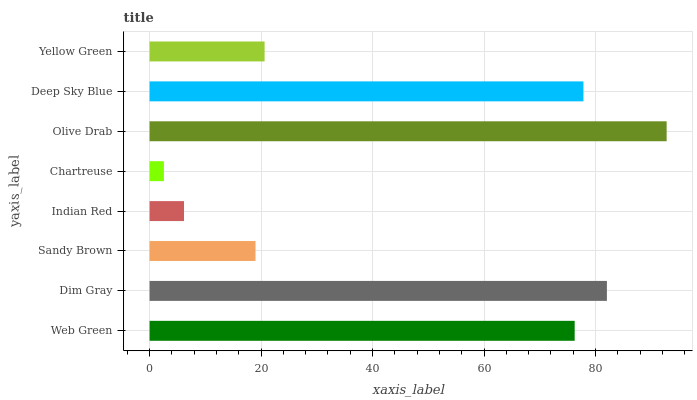Is Chartreuse the minimum?
Answer yes or no. Yes. Is Olive Drab the maximum?
Answer yes or no. Yes. Is Dim Gray the minimum?
Answer yes or no. No. Is Dim Gray the maximum?
Answer yes or no. No. Is Dim Gray greater than Web Green?
Answer yes or no. Yes. Is Web Green less than Dim Gray?
Answer yes or no. Yes. Is Web Green greater than Dim Gray?
Answer yes or no. No. Is Dim Gray less than Web Green?
Answer yes or no. No. Is Web Green the high median?
Answer yes or no. Yes. Is Yellow Green the low median?
Answer yes or no. Yes. Is Indian Red the high median?
Answer yes or no. No. Is Chartreuse the low median?
Answer yes or no. No. 